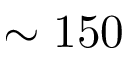Convert formula to latex. <formula><loc_0><loc_0><loc_500><loc_500>\sim 1 5 0</formula> 